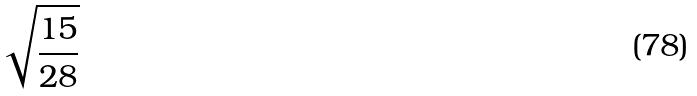<formula> <loc_0><loc_0><loc_500><loc_500>\sqrt { \frac { 1 5 } { 2 8 } }</formula> 